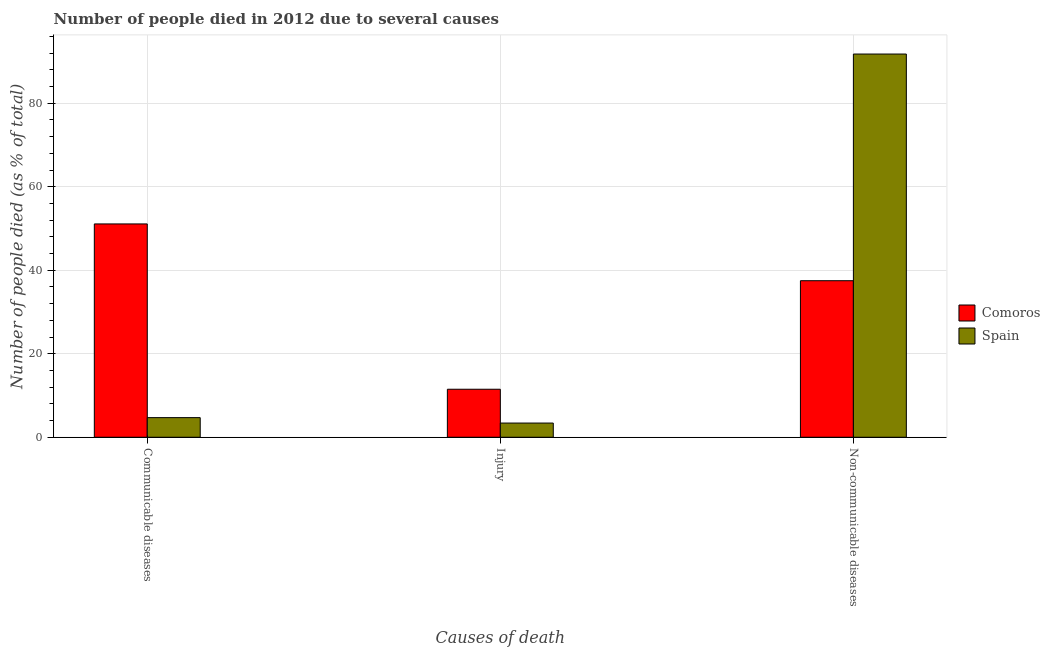How many different coloured bars are there?
Provide a short and direct response. 2. How many bars are there on the 3rd tick from the right?
Your answer should be compact. 2. What is the label of the 1st group of bars from the left?
Give a very brief answer. Communicable diseases. Across all countries, what is the maximum number of people who died of communicable diseases?
Offer a terse response. 51.1. Across all countries, what is the minimum number of people who dies of non-communicable diseases?
Provide a succinct answer. 37.5. In which country was the number of people who died of injury maximum?
Your response must be concise. Comoros. In which country was the number of people who dies of non-communicable diseases minimum?
Offer a terse response. Comoros. What is the total number of people who died of communicable diseases in the graph?
Provide a succinct answer. 55.8. What is the difference between the number of people who died of communicable diseases in Comoros and that in Spain?
Your response must be concise. 46.4. What is the difference between the number of people who dies of non-communicable diseases in Comoros and the number of people who died of communicable diseases in Spain?
Provide a short and direct response. 32.8. What is the average number of people who dies of non-communicable diseases per country?
Provide a short and direct response. 64.65. What is the difference between the number of people who died of injury and number of people who died of communicable diseases in Spain?
Offer a very short reply. -1.3. What is the ratio of the number of people who died of injury in Comoros to that in Spain?
Keep it short and to the point. 3.38. Is the number of people who dies of non-communicable diseases in Spain less than that in Comoros?
Provide a succinct answer. No. What is the difference between the highest and the second highest number of people who dies of non-communicable diseases?
Your answer should be very brief. 54.3. What is the difference between the highest and the lowest number of people who died of communicable diseases?
Offer a very short reply. 46.4. In how many countries, is the number of people who dies of non-communicable diseases greater than the average number of people who dies of non-communicable diseases taken over all countries?
Your answer should be compact. 1. Is the sum of the number of people who died of injury in Spain and Comoros greater than the maximum number of people who died of communicable diseases across all countries?
Make the answer very short. No. What does the 1st bar from the right in Injury represents?
Make the answer very short. Spain. Are all the bars in the graph horizontal?
Provide a succinct answer. No. Does the graph contain grids?
Ensure brevity in your answer.  Yes. What is the title of the graph?
Provide a succinct answer. Number of people died in 2012 due to several causes. What is the label or title of the X-axis?
Your answer should be very brief. Causes of death. What is the label or title of the Y-axis?
Make the answer very short. Number of people died (as % of total). What is the Number of people died (as % of total) of Comoros in Communicable diseases?
Provide a succinct answer. 51.1. What is the Number of people died (as % of total) in Spain in Communicable diseases?
Your answer should be very brief. 4.7. What is the Number of people died (as % of total) of Spain in Injury?
Your answer should be very brief. 3.4. What is the Number of people died (as % of total) of Comoros in Non-communicable diseases?
Provide a short and direct response. 37.5. What is the Number of people died (as % of total) in Spain in Non-communicable diseases?
Provide a short and direct response. 91.8. Across all Causes of death, what is the maximum Number of people died (as % of total) of Comoros?
Provide a succinct answer. 51.1. Across all Causes of death, what is the maximum Number of people died (as % of total) in Spain?
Provide a succinct answer. 91.8. What is the total Number of people died (as % of total) in Comoros in the graph?
Provide a succinct answer. 100.1. What is the total Number of people died (as % of total) of Spain in the graph?
Keep it short and to the point. 99.9. What is the difference between the Number of people died (as % of total) in Comoros in Communicable diseases and that in Injury?
Keep it short and to the point. 39.6. What is the difference between the Number of people died (as % of total) in Spain in Communicable diseases and that in Injury?
Provide a succinct answer. 1.3. What is the difference between the Number of people died (as % of total) of Spain in Communicable diseases and that in Non-communicable diseases?
Provide a short and direct response. -87.1. What is the difference between the Number of people died (as % of total) of Spain in Injury and that in Non-communicable diseases?
Keep it short and to the point. -88.4. What is the difference between the Number of people died (as % of total) in Comoros in Communicable diseases and the Number of people died (as % of total) in Spain in Injury?
Ensure brevity in your answer.  47.7. What is the difference between the Number of people died (as % of total) of Comoros in Communicable diseases and the Number of people died (as % of total) of Spain in Non-communicable diseases?
Provide a short and direct response. -40.7. What is the difference between the Number of people died (as % of total) of Comoros in Injury and the Number of people died (as % of total) of Spain in Non-communicable diseases?
Offer a terse response. -80.3. What is the average Number of people died (as % of total) of Comoros per Causes of death?
Your response must be concise. 33.37. What is the average Number of people died (as % of total) in Spain per Causes of death?
Offer a terse response. 33.3. What is the difference between the Number of people died (as % of total) of Comoros and Number of people died (as % of total) of Spain in Communicable diseases?
Offer a terse response. 46.4. What is the difference between the Number of people died (as % of total) in Comoros and Number of people died (as % of total) in Spain in Non-communicable diseases?
Keep it short and to the point. -54.3. What is the ratio of the Number of people died (as % of total) of Comoros in Communicable diseases to that in Injury?
Provide a succinct answer. 4.44. What is the ratio of the Number of people died (as % of total) in Spain in Communicable diseases to that in Injury?
Ensure brevity in your answer.  1.38. What is the ratio of the Number of people died (as % of total) in Comoros in Communicable diseases to that in Non-communicable diseases?
Provide a succinct answer. 1.36. What is the ratio of the Number of people died (as % of total) in Spain in Communicable diseases to that in Non-communicable diseases?
Keep it short and to the point. 0.05. What is the ratio of the Number of people died (as % of total) in Comoros in Injury to that in Non-communicable diseases?
Your answer should be very brief. 0.31. What is the ratio of the Number of people died (as % of total) in Spain in Injury to that in Non-communicable diseases?
Offer a very short reply. 0.04. What is the difference between the highest and the second highest Number of people died (as % of total) of Spain?
Your answer should be very brief. 87.1. What is the difference between the highest and the lowest Number of people died (as % of total) in Comoros?
Your answer should be very brief. 39.6. What is the difference between the highest and the lowest Number of people died (as % of total) of Spain?
Provide a succinct answer. 88.4. 